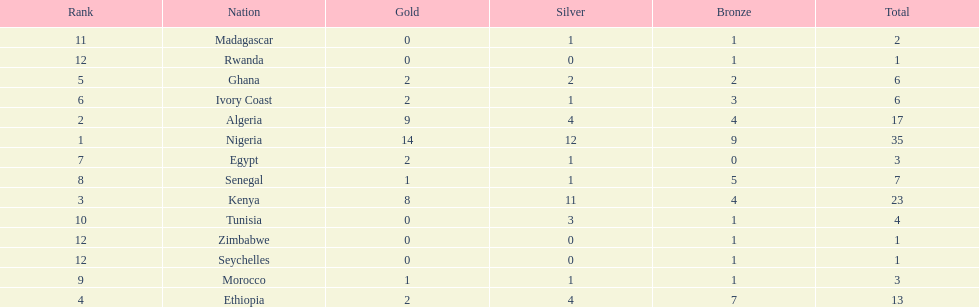Total number of bronze medals nigeria earned? 9. 